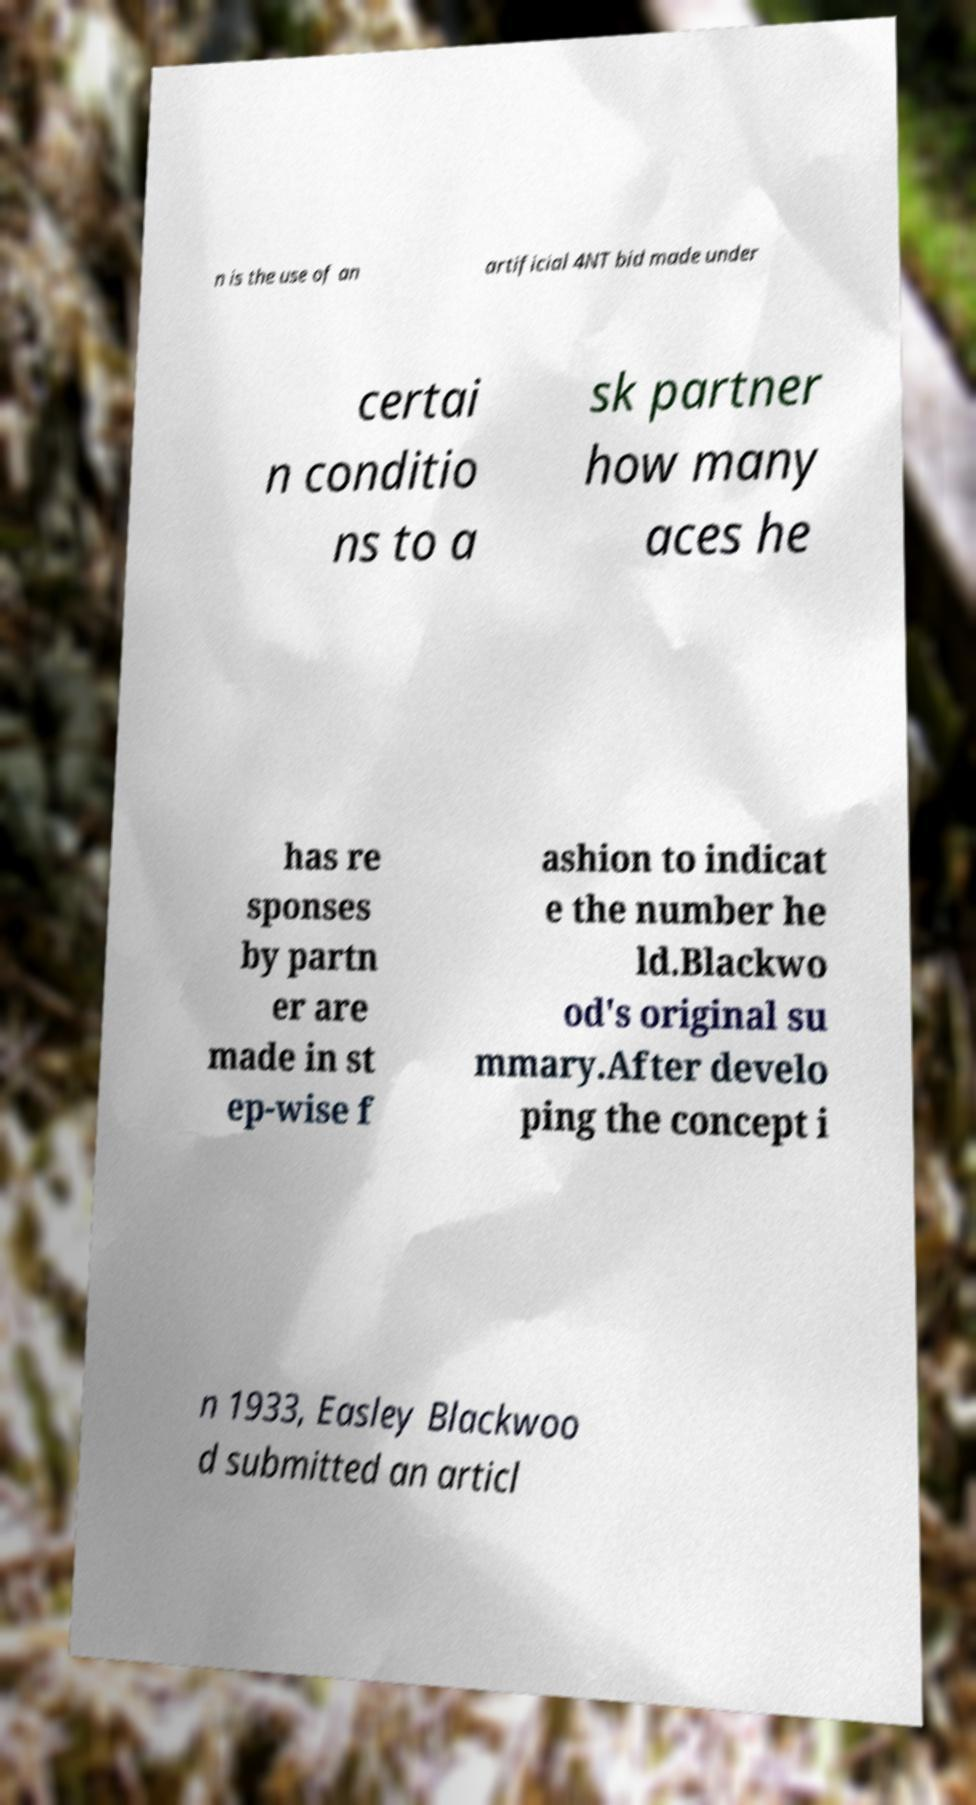Please identify and transcribe the text found in this image. n is the use of an artificial 4NT bid made under certai n conditio ns to a sk partner how many aces he has re sponses by partn er are made in st ep-wise f ashion to indicat e the number he ld.Blackwo od's original su mmary.After develo ping the concept i n 1933, Easley Blackwoo d submitted an articl 